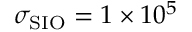Convert formula to latex. <formula><loc_0><loc_0><loc_500><loc_500>\sigma _ { S I O } = 1 \times 1 0 ^ { 5 }</formula> 